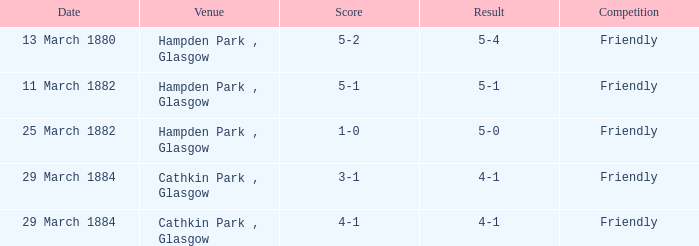Which element has a 5-1 score attached to it? 5-1. 